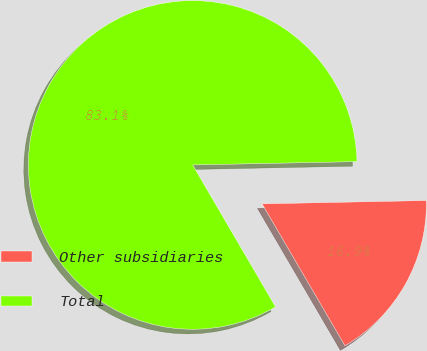Convert chart to OTSL. <chart><loc_0><loc_0><loc_500><loc_500><pie_chart><fcel>Other subsidiaries<fcel>Total<nl><fcel>16.91%<fcel>83.09%<nl></chart> 